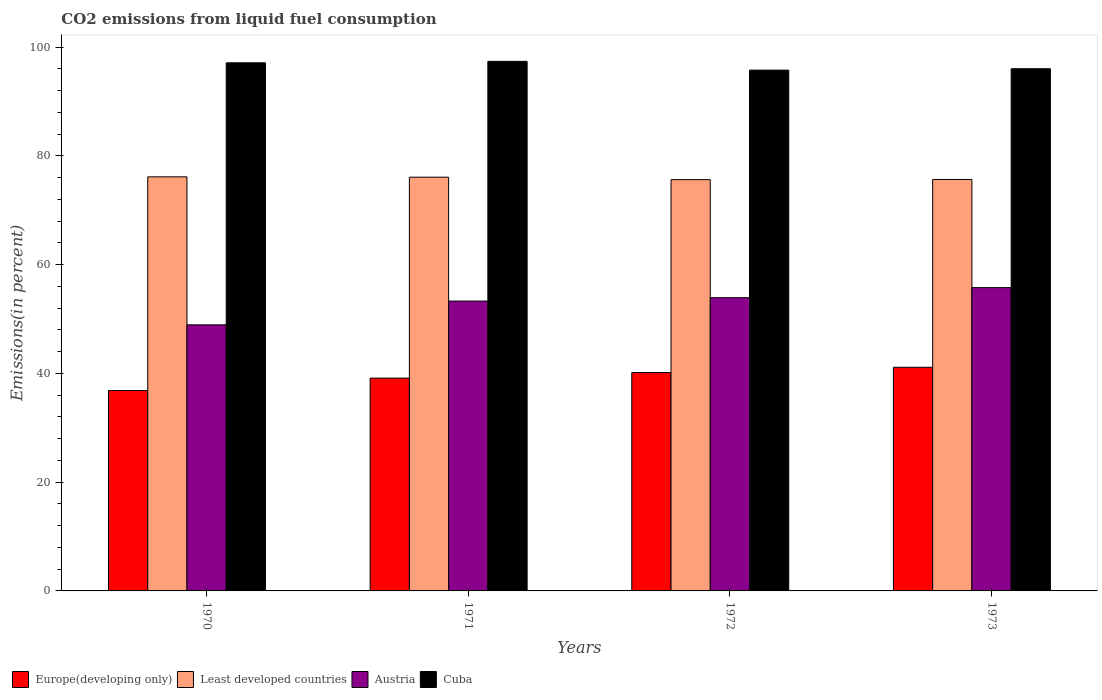How many different coloured bars are there?
Make the answer very short. 4. How many groups of bars are there?
Your answer should be compact. 4. Are the number of bars on each tick of the X-axis equal?
Provide a succinct answer. Yes. How many bars are there on the 3rd tick from the right?
Your answer should be compact. 4. What is the label of the 1st group of bars from the left?
Provide a succinct answer. 1970. In how many cases, is the number of bars for a given year not equal to the number of legend labels?
Your answer should be very brief. 0. What is the total CO2 emitted in Austria in 1970?
Your answer should be compact. 48.92. Across all years, what is the maximum total CO2 emitted in Cuba?
Keep it short and to the point. 97.36. Across all years, what is the minimum total CO2 emitted in Cuba?
Your response must be concise. 95.75. In which year was the total CO2 emitted in Austria maximum?
Give a very brief answer. 1973. In which year was the total CO2 emitted in Europe(developing only) minimum?
Keep it short and to the point. 1970. What is the total total CO2 emitted in Least developed countries in the graph?
Ensure brevity in your answer.  303.45. What is the difference between the total CO2 emitted in Austria in 1971 and that in 1972?
Make the answer very short. -0.61. What is the difference between the total CO2 emitted in Cuba in 1973 and the total CO2 emitted in Austria in 1972?
Your answer should be compact. 42.1. What is the average total CO2 emitted in Austria per year?
Offer a terse response. 52.97. In the year 1972, what is the difference between the total CO2 emitted in Europe(developing only) and total CO2 emitted in Least developed countries?
Provide a short and direct response. -35.47. In how many years, is the total CO2 emitted in Austria greater than 28 %?
Ensure brevity in your answer.  4. What is the ratio of the total CO2 emitted in Least developed countries in 1972 to that in 1973?
Keep it short and to the point. 1. Is the total CO2 emitted in Cuba in 1971 less than that in 1973?
Give a very brief answer. No. What is the difference between the highest and the second highest total CO2 emitted in Least developed countries?
Keep it short and to the point. 0.07. What is the difference between the highest and the lowest total CO2 emitted in Least developed countries?
Make the answer very short. 0.51. In how many years, is the total CO2 emitted in Least developed countries greater than the average total CO2 emitted in Least developed countries taken over all years?
Offer a terse response. 2. What does the 4th bar from the right in 1973 represents?
Give a very brief answer. Europe(developing only). How many years are there in the graph?
Your answer should be compact. 4. Where does the legend appear in the graph?
Offer a terse response. Bottom left. How are the legend labels stacked?
Your response must be concise. Horizontal. What is the title of the graph?
Offer a very short reply. CO2 emissions from liquid fuel consumption. What is the label or title of the Y-axis?
Provide a succinct answer. Emissions(in percent). What is the Emissions(in percent) in Europe(developing only) in 1970?
Offer a terse response. 36.85. What is the Emissions(in percent) of Least developed countries in 1970?
Your response must be concise. 76.13. What is the Emissions(in percent) of Austria in 1970?
Keep it short and to the point. 48.92. What is the Emissions(in percent) of Cuba in 1970?
Provide a short and direct response. 97.09. What is the Emissions(in percent) in Europe(developing only) in 1971?
Provide a succinct answer. 39.13. What is the Emissions(in percent) of Least developed countries in 1971?
Keep it short and to the point. 76.06. What is the Emissions(in percent) in Austria in 1971?
Your answer should be very brief. 53.29. What is the Emissions(in percent) in Cuba in 1971?
Offer a very short reply. 97.36. What is the Emissions(in percent) of Europe(developing only) in 1972?
Offer a terse response. 40.15. What is the Emissions(in percent) in Least developed countries in 1972?
Provide a succinct answer. 75.62. What is the Emissions(in percent) in Austria in 1972?
Your response must be concise. 53.91. What is the Emissions(in percent) of Cuba in 1972?
Your answer should be very brief. 95.75. What is the Emissions(in percent) in Europe(developing only) in 1973?
Make the answer very short. 41.12. What is the Emissions(in percent) in Least developed countries in 1973?
Make the answer very short. 75.65. What is the Emissions(in percent) in Austria in 1973?
Give a very brief answer. 55.76. What is the Emissions(in percent) of Cuba in 1973?
Offer a very short reply. 96.01. Across all years, what is the maximum Emissions(in percent) of Europe(developing only)?
Your answer should be compact. 41.12. Across all years, what is the maximum Emissions(in percent) of Least developed countries?
Your answer should be compact. 76.13. Across all years, what is the maximum Emissions(in percent) in Austria?
Your answer should be compact. 55.76. Across all years, what is the maximum Emissions(in percent) in Cuba?
Give a very brief answer. 97.36. Across all years, what is the minimum Emissions(in percent) in Europe(developing only)?
Your answer should be compact. 36.85. Across all years, what is the minimum Emissions(in percent) of Least developed countries?
Ensure brevity in your answer.  75.62. Across all years, what is the minimum Emissions(in percent) in Austria?
Ensure brevity in your answer.  48.92. Across all years, what is the minimum Emissions(in percent) in Cuba?
Provide a succinct answer. 95.75. What is the total Emissions(in percent) in Europe(developing only) in the graph?
Keep it short and to the point. 157.24. What is the total Emissions(in percent) in Least developed countries in the graph?
Your answer should be compact. 303.45. What is the total Emissions(in percent) in Austria in the graph?
Ensure brevity in your answer.  211.89. What is the total Emissions(in percent) of Cuba in the graph?
Offer a terse response. 386.21. What is the difference between the Emissions(in percent) in Europe(developing only) in 1970 and that in 1971?
Provide a short and direct response. -2.28. What is the difference between the Emissions(in percent) in Least developed countries in 1970 and that in 1971?
Your answer should be very brief. 0.07. What is the difference between the Emissions(in percent) of Austria in 1970 and that in 1971?
Your answer should be compact. -4.37. What is the difference between the Emissions(in percent) in Cuba in 1970 and that in 1971?
Provide a succinct answer. -0.27. What is the difference between the Emissions(in percent) of Europe(developing only) in 1970 and that in 1972?
Provide a short and direct response. -3.3. What is the difference between the Emissions(in percent) in Least developed countries in 1970 and that in 1972?
Keep it short and to the point. 0.51. What is the difference between the Emissions(in percent) of Austria in 1970 and that in 1972?
Keep it short and to the point. -4.99. What is the difference between the Emissions(in percent) in Cuba in 1970 and that in 1972?
Provide a short and direct response. 1.34. What is the difference between the Emissions(in percent) in Europe(developing only) in 1970 and that in 1973?
Make the answer very short. -4.27. What is the difference between the Emissions(in percent) in Least developed countries in 1970 and that in 1973?
Keep it short and to the point. 0.48. What is the difference between the Emissions(in percent) in Austria in 1970 and that in 1973?
Make the answer very short. -6.84. What is the difference between the Emissions(in percent) in Cuba in 1970 and that in 1973?
Provide a short and direct response. 1.09. What is the difference between the Emissions(in percent) of Europe(developing only) in 1971 and that in 1972?
Offer a very short reply. -1.02. What is the difference between the Emissions(in percent) of Least developed countries in 1971 and that in 1972?
Your answer should be compact. 0.45. What is the difference between the Emissions(in percent) in Austria in 1971 and that in 1972?
Your response must be concise. -0.61. What is the difference between the Emissions(in percent) of Cuba in 1971 and that in 1972?
Provide a short and direct response. 1.61. What is the difference between the Emissions(in percent) of Europe(developing only) in 1971 and that in 1973?
Give a very brief answer. -1.99. What is the difference between the Emissions(in percent) in Least developed countries in 1971 and that in 1973?
Your response must be concise. 0.42. What is the difference between the Emissions(in percent) of Austria in 1971 and that in 1973?
Your answer should be very brief. -2.47. What is the difference between the Emissions(in percent) in Cuba in 1971 and that in 1973?
Give a very brief answer. 1.36. What is the difference between the Emissions(in percent) in Europe(developing only) in 1972 and that in 1973?
Ensure brevity in your answer.  -0.97. What is the difference between the Emissions(in percent) in Least developed countries in 1972 and that in 1973?
Provide a succinct answer. -0.03. What is the difference between the Emissions(in percent) of Austria in 1972 and that in 1973?
Your answer should be very brief. -1.85. What is the difference between the Emissions(in percent) in Cuba in 1972 and that in 1973?
Your response must be concise. -0.25. What is the difference between the Emissions(in percent) in Europe(developing only) in 1970 and the Emissions(in percent) in Least developed countries in 1971?
Provide a short and direct response. -39.21. What is the difference between the Emissions(in percent) in Europe(developing only) in 1970 and the Emissions(in percent) in Austria in 1971?
Ensure brevity in your answer.  -16.44. What is the difference between the Emissions(in percent) in Europe(developing only) in 1970 and the Emissions(in percent) in Cuba in 1971?
Give a very brief answer. -60.51. What is the difference between the Emissions(in percent) of Least developed countries in 1970 and the Emissions(in percent) of Austria in 1971?
Offer a very short reply. 22.84. What is the difference between the Emissions(in percent) of Least developed countries in 1970 and the Emissions(in percent) of Cuba in 1971?
Make the answer very short. -21.23. What is the difference between the Emissions(in percent) of Austria in 1970 and the Emissions(in percent) of Cuba in 1971?
Offer a terse response. -48.44. What is the difference between the Emissions(in percent) in Europe(developing only) in 1970 and the Emissions(in percent) in Least developed countries in 1972?
Keep it short and to the point. -38.77. What is the difference between the Emissions(in percent) in Europe(developing only) in 1970 and the Emissions(in percent) in Austria in 1972?
Offer a very short reply. -17.06. What is the difference between the Emissions(in percent) in Europe(developing only) in 1970 and the Emissions(in percent) in Cuba in 1972?
Provide a short and direct response. -58.9. What is the difference between the Emissions(in percent) of Least developed countries in 1970 and the Emissions(in percent) of Austria in 1972?
Provide a succinct answer. 22.22. What is the difference between the Emissions(in percent) in Least developed countries in 1970 and the Emissions(in percent) in Cuba in 1972?
Offer a terse response. -19.62. What is the difference between the Emissions(in percent) in Austria in 1970 and the Emissions(in percent) in Cuba in 1972?
Provide a succinct answer. -46.83. What is the difference between the Emissions(in percent) in Europe(developing only) in 1970 and the Emissions(in percent) in Least developed countries in 1973?
Make the answer very short. -38.8. What is the difference between the Emissions(in percent) in Europe(developing only) in 1970 and the Emissions(in percent) in Austria in 1973?
Ensure brevity in your answer.  -18.91. What is the difference between the Emissions(in percent) of Europe(developing only) in 1970 and the Emissions(in percent) of Cuba in 1973?
Your answer should be compact. -59.16. What is the difference between the Emissions(in percent) of Least developed countries in 1970 and the Emissions(in percent) of Austria in 1973?
Your answer should be very brief. 20.37. What is the difference between the Emissions(in percent) of Least developed countries in 1970 and the Emissions(in percent) of Cuba in 1973?
Your answer should be compact. -19.88. What is the difference between the Emissions(in percent) in Austria in 1970 and the Emissions(in percent) in Cuba in 1973?
Offer a terse response. -47.08. What is the difference between the Emissions(in percent) of Europe(developing only) in 1971 and the Emissions(in percent) of Least developed countries in 1972?
Provide a succinct answer. -36.49. What is the difference between the Emissions(in percent) of Europe(developing only) in 1971 and the Emissions(in percent) of Austria in 1972?
Offer a very short reply. -14.78. What is the difference between the Emissions(in percent) of Europe(developing only) in 1971 and the Emissions(in percent) of Cuba in 1972?
Your answer should be compact. -56.62. What is the difference between the Emissions(in percent) of Least developed countries in 1971 and the Emissions(in percent) of Austria in 1972?
Your answer should be compact. 22.16. What is the difference between the Emissions(in percent) of Least developed countries in 1971 and the Emissions(in percent) of Cuba in 1972?
Make the answer very short. -19.69. What is the difference between the Emissions(in percent) of Austria in 1971 and the Emissions(in percent) of Cuba in 1972?
Provide a short and direct response. -42.46. What is the difference between the Emissions(in percent) in Europe(developing only) in 1971 and the Emissions(in percent) in Least developed countries in 1973?
Make the answer very short. -36.52. What is the difference between the Emissions(in percent) of Europe(developing only) in 1971 and the Emissions(in percent) of Austria in 1973?
Your answer should be very brief. -16.64. What is the difference between the Emissions(in percent) in Europe(developing only) in 1971 and the Emissions(in percent) in Cuba in 1973?
Give a very brief answer. -56.88. What is the difference between the Emissions(in percent) of Least developed countries in 1971 and the Emissions(in percent) of Austria in 1973?
Keep it short and to the point. 20.3. What is the difference between the Emissions(in percent) in Least developed countries in 1971 and the Emissions(in percent) in Cuba in 1973?
Your answer should be compact. -19.94. What is the difference between the Emissions(in percent) in Austria in 1971 and the Emissions(in percent) in Cuba in 1973?
Give a very brief answer. -42.71. What is the difference between the Emissions(in percent) in Europe(developing only) in 1972 and the Emissions(in percent) in Least developed countries in 1973?
Your answer should be very brief. -35.5. What is the difference between the Emissions(in percent) in Europe(developing only) in 1972 and the Emissions(in percent) in Austria in 1973?
Ensure brevity in your answer.  -15.62. What is the difference between the Emissions(in percent) of Europe(developing only) in 1972 and the Emissions(in percent) of Cuba in 1973?
Offer a very short reply. -55.86. What is the difference between the Emissions(in percent) in Least developed countries in 1972 and the Emissions(in percent) in Austria in 1973?
Keep it short and to the point. 19.85. What is the difference between the Emissions(in percent) in Least developed countries in 1972 and the Emissions(in percent) in Cuba in 1973?
Ensure brevity in your answer.  -20.39. What is the difference between the Emissions(in percent) of Austria in 1972 and the Emissions(in percent) of Cuba in 1973?
Your response must be concise. -42.1. What is the average Emissions(in percent) in Europe(developing only) per year?
Ensure brevity in your answer.  39.31. What is the average Emissions(in percent) of Least developed countries per year?
Give a very brief answer. 75.86. What is the average Emissions(in percent) in Austria per year?
Your response must be concise. 52.97. What is the average Emissions(in percent) of Cuba per year?
Your response must be concise. 96.55. In the year 1970, what is the difference between the Emissions(in percent) of Europe(developing only) and Emissions(in percent) of Least developed countries?
Ensure brevity in your answer.  -39.28. In the year 1970, what is the difference between the Emissions(in percent) of Europe(developing only) and Emissions(in percent) of Austria?
Your answer should be compact. -12.07. In the year 1970, what is the difference between the Emissions(in percent) of Europe(developing only) and Emissions(in percent) of Cuba?
Your answer should be compact. -60.24. In the year 1970, what is the difference between the Emissions(in percent) in Least developed countries and Emissions(in percent) in Austria?
Offer a very short reply. 27.21. In the year 1970, what is the difference between the Emissions(in percent) in Least developed countries and Emissions(in percent) in Cuba?
Your response must be concise. -20.96. In the year 1970, what is the difference between the Emissions(in percent) in Austria and Emissions(in percent) in Cuba?
Your answer should be very brief. -48.17. In the year 1971, what is the difference between the Emissions(in percent) in Europe(developing only) and Emissions(in percent) in Least developed countries?
Ensure brevity in your answer.  -36.94. In the year 1971, what is the difference between the Emissions(in percent) of Europe(developing only) and Emissions(in percent) of Austria?
Your response must be concise. -14.17. In the year 1971, what is the difference between the Emissions(in percent) in Europe(developing only) and Emissions(in percent) in Cuba?
Keep it short and to the point. -58.24. In the year 1971, what is the difference between the Emissions(in percent) in Least developed countries and Emissions(in percent) in Austria?
Provide a short and direct response. 22.77. In the year 1971, what is the difference between the Emissions(in percent) of Least developed countries and Emissions(in percent) of Cuba?
Your answer should be very brief. -21.3. In the year 1971, what is the difference between the Emissions(in percent) in Austria and Emissions(in percent) in Cuba?
Keep it short and to the point. -44.07. In the year 1972, what is the difference between the Emissions(in percent) in Europe(developing only) and Emissions(in percent) in Least developed countries?
Keep it short and to the point. -35.47. In the year 1972, what is the difference between the Emissions(in percent) of Europe(developing only) and Emissions(in percent) of Austria?
Make the answer very short. -13.76. In the year 1972, what is the difference between the Emissions(in percent) of Europe(developing only) and Emissions(in percent) of Cuba?
Provide a succinct answer. -55.6. In the year 1972, what is the difference between the Emissions(in percent) of Least developed countries and Emissions(in percent) of Austria?
Your answer should be compact. 21.71. In the year 1972, what is the difference between the Emissions(in percent) of Least developed countries and Emissions(in percent) of Cuba?
Your answer should be very brief. -20.14. In the year 1972, what is the difference between the Emissions(in percent) of Austria and Emissions(in percent) of Cuba?
Your answer should be compact. -41.84. In the year 1973, what is the difference between the Emissions(in percent) of Europe(developing only) and Emissions(in percent) of Least developed countries?
Your answer should be very brief. -34.53. In the year 1973, what is the difference between the Emissions(in percent) in Europe(developing only) and Emissions(in percent) in Austria?
Your answer should be compact. -14.64. In the year 1973, what is the difference between the Emissions(in percent) of Europe(developing only) and Emissions(in percent) of Cuba?
Keep it short and to the point. -54.89. In the year 1973, what is the difference between the Emissions(in percent) in Least developed countries and Emissions(in percent) in Austria?
Provide a succinct answer. 19.88. In the year 1973, what is the difference between the Emissions(in percent) in Least developed countries and Emissions(in percent) in Cuba?
Your answer should be compact. -20.36. In the year 1973, what is the difference between the Emissions(in percent) of Austria and Emissions(in percent) of Cuba?
Provide a short and direct response. -40.24. What is the ratio of the Emissions(in percent) of Europe(developing only) in 1970 to that in 1971?
Make the answer very short. 0.94. What is the ratio of the Emissions(in percent) in Least developed countries in 1970 to that in 1971?
Make the answer very short. 1. What is the ratio of the Emissions(in percent) of Austria in 1970 to that in 1971?
Offer a very short reply. 0.92. What is the ratio of the Emissions(in percent) of Europe(developing only) in 1970 to that in 1972?
Give a very brief answer. 0.92. What is the ratio of the Emissions(in percent) of Least developed countries in 1970 to that in 1972?
Ensure brevity in your answer.  1.01. What is the ratio of the Emissions(in percent) of Austria in 1970 to that in 1972?
Provide a succinct answer. 0.91. What is the ratio of the Emissions(in percent) of Europe(developing only) in 1970 to that in 1973?
Your answer should be compact. 0.9. What is the ratio of the Emissions(in percent) of Least developed countries in 1970 to that in 1973?
Your answer should be compact. 1.01. What is the ratio of the Emissions(in percent) of Austria in 1970 to that in 1973?
Give a very brief answer. 0.88. What is the ratio of the Emissions(in percent) of Cuba in 1970 to that in 1973?
Offer a very short reply. 1.01. What is the ratio of the Emissions(in percent) of Europe(developing only) in 1971 to that in 1972?
Offer a terse response. 0.97. What is the ratio of the Emissions(in percent) of Least developed countries in 1971 to that in 1972?
Keep it short and to the point. 1.01. What is the ratio of the Emissions(in percent) in Cuba in 1971 to that in 1972?
Your response must be concise. 1.02. What is the ratio of the Emissions(in percent) of Europe(developing only) in 1971 to that in 1973?
Provide a succinct answer. 0.95. What is the ratio of the Emissions(in percent) in Least developed countries in 1971 to that in 1973?
Give a very brief answer. 1.01. What is the ratio of the Emissions(in percent) in Austria in 1971 to that in 1973?
Your answer should be very brief. 0.96. What is the ratio of the Emissions(in percent) in Cuba in 1971 to that in 1973?
Give a very brief answer. 1.01. What is the ratio of the Emissions(in percent) in Europe(developing only) in 1972 to that in 1973?
Your answer should be very brief. 0.98. What is the ratio of the Emissions(in percent) in Least developed countries in 1972 to that in 1973?
Your answer should be very brief. 1. What is the ratio of the Emissions(in percent) of Austria in 1972 to that in 1973?
Your response must be concise. 0.97. What is the ratio of the Emissions(in percent) of Cuba in 1972 to that in 1973?
Keep it short and to the point. 1. What is the difference between the highest and the second highest Emissions(in percent) of Europe(developing only)?
Your response must be concise. 0.97. What is the difference between the highest and the second highest Emissions(in percent) in Least developed countries?
Provide a succinct answer. 0.07. What is the difference between the highest and the second highest Emissions(in percent) of Austria?
Make the answer very short. 1.85. What is the difference between the highest and the second highest Emissions(in percent) of Cuba?
Provide a short and direct response. 0.27. What is the difference between the highest and the lowest Emissions(in percent) in Europe(developing only)?
Offer a very short reply. 4.27. What is the difference between the highest and the lowest Emissions(in percent) in Least developed countries?
Your answer should be very brief. 0.51. What is the difference between the highest and the lowest Emissions(in percent) of Austria?
Give a very brief answer. 6.84. What is the difference between the highest and the lowest Emissions(in percent) of Cuba?
Provide a short and direct response. 1.61. 